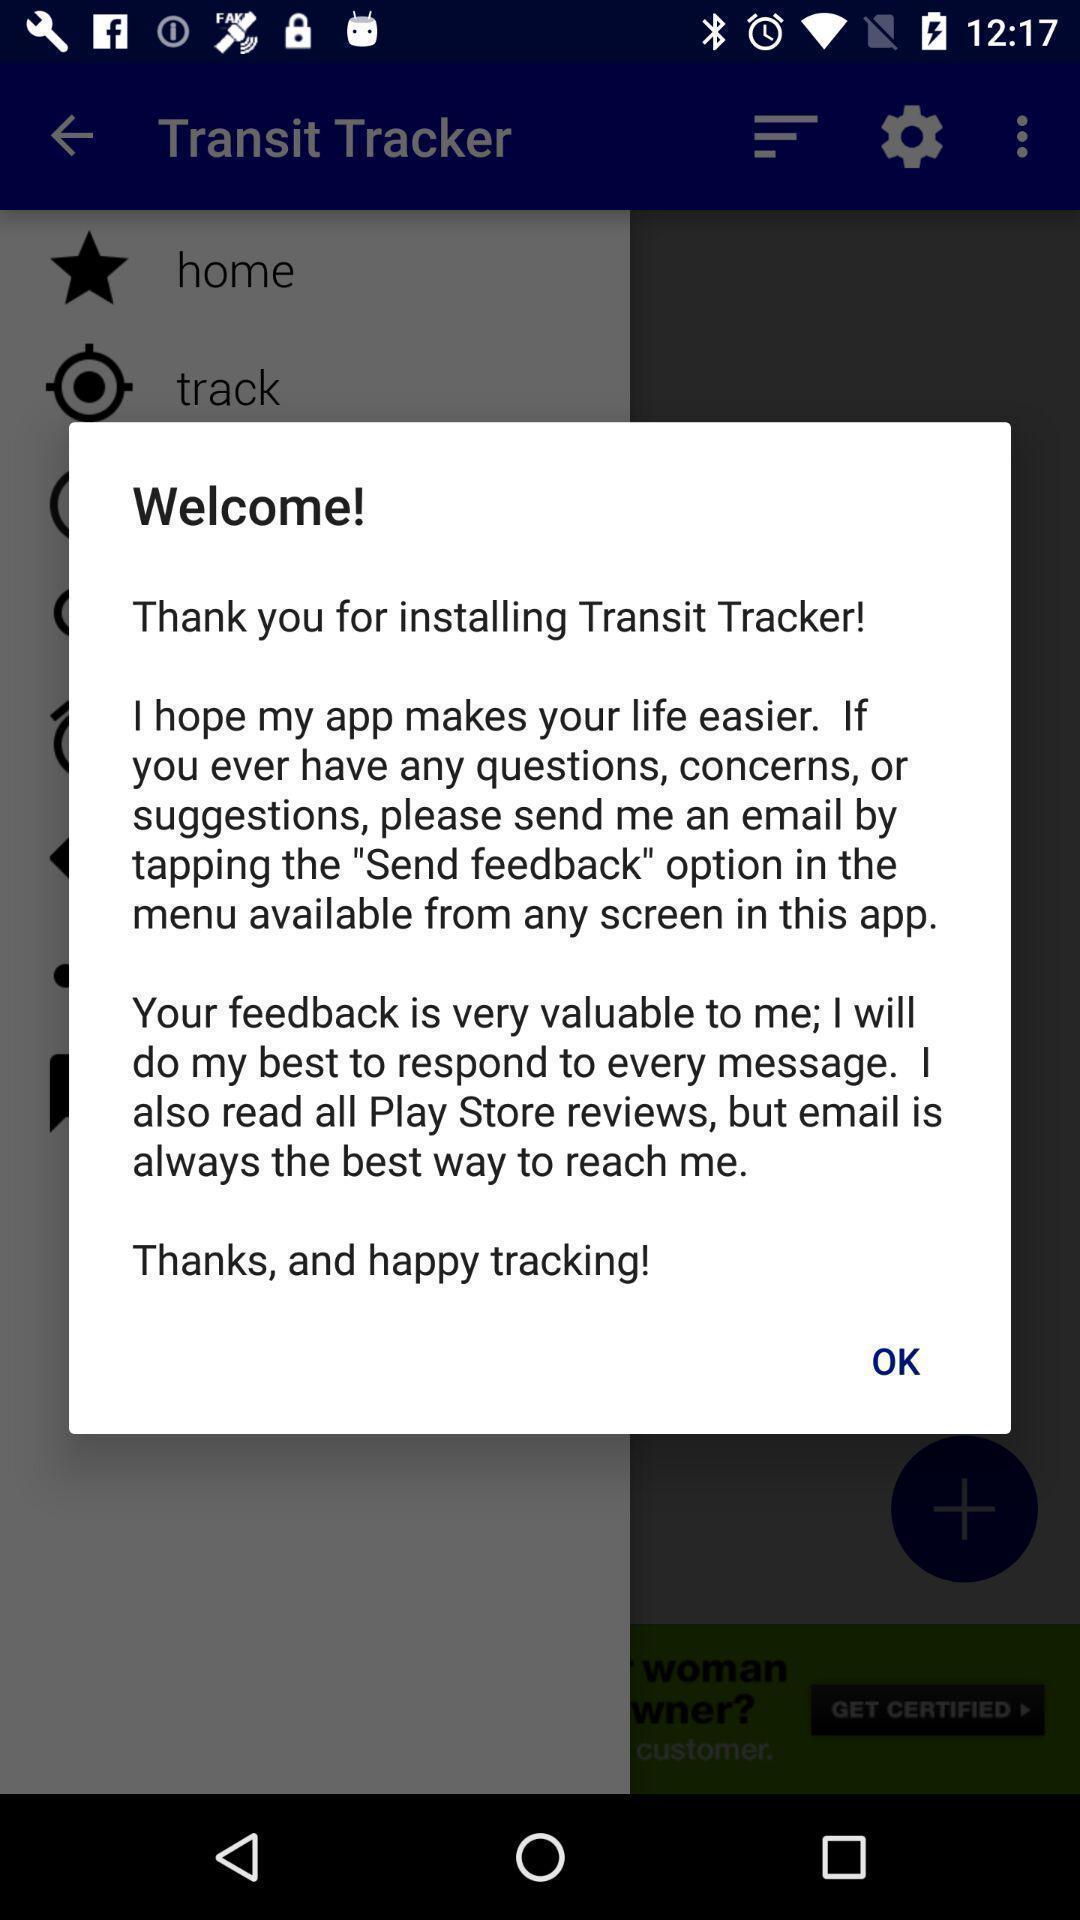Describe the content in this image. Pop-up window showing welcome page of tracking application. 